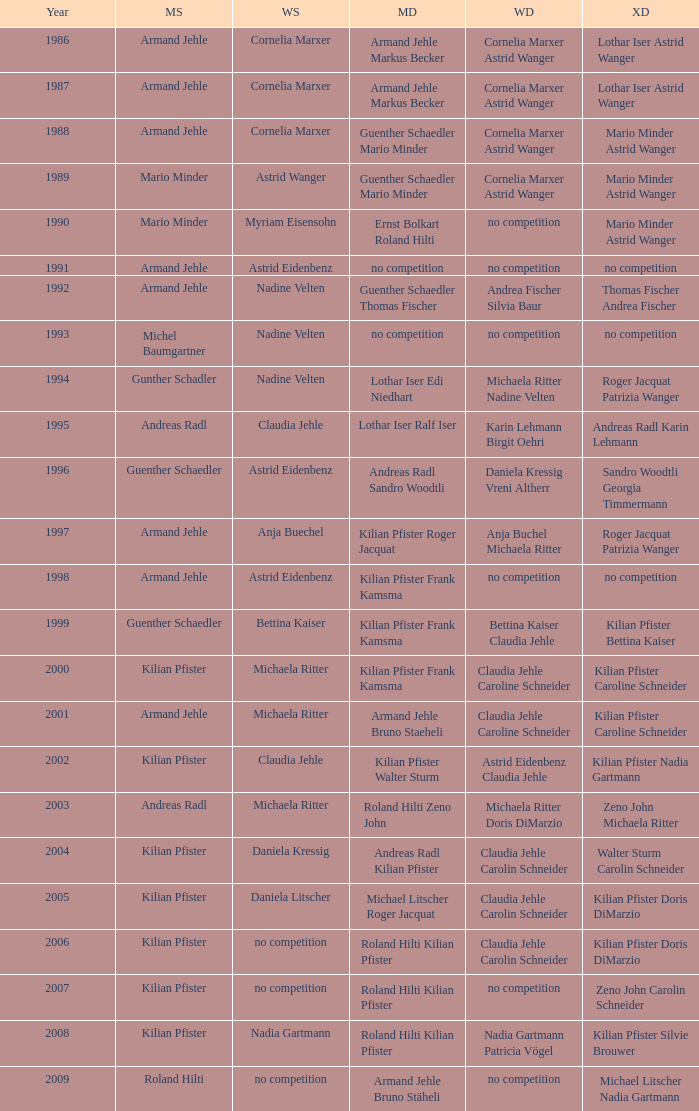What is the most current year where the women's doubles champions are astrid eidenbenz claudia jehle 2002.0. Would you be able to parse every entry in this table? {'header': ['Year', 'MS', 'WS', 'MD', 'WD', 'XD'], 'rows': [['1986', 'Armand Jehle', 'Cornelia Marxer', 'Armand Jehle Markus Becker', 'Cornelia Marxer Astrid Wanger', 'Lothar Iser Astrid Wanger'], ['1987', 'Armand Jehle', 'Cornelia Marxer', 'Armand Jehle Markus Becker', 'Cornelia Marxer Astrid Wanger', 'Lothar Iser Astrid Wanger'], ['1988', 'Armand Jehle', 'Cornelia Marxer', 'Guenther Schaedler Mario Minder', 'Cornelia Marxer Astrid Wanger', 'Mario Minder Astrid Wanger'], ['1989', 'Mario Minder', 'Astrid Wanger', 'Guenther Schaedler Mario Minder', 'Cornelia Marxer Astrid Wanger', 'Mario Minder Astrid Wanger'], ['1990', 'Mario Minder', 'Myriam Eisensohn', 'Ernst Bolkart Roland Hilti', 'no competition', 'Mario Minder Astrid Wanger'], ['1991', 'Armand Jehle', 'Astrid Eidenbenz', 'no competition', 'no competition', 'no competition'], ['1992', 'Armand Jehle', 'Nadine Velten', 'Guenther Schaedler Thomas Fischer', 'Andrea Fischer Silvia Baur', 'Thomas Fischer Andrea Fischer'], ['1993', 'Michel Baumgartner', 'Nadine Velten', 'no competition', 'no competition', 'no competition'], ['1994', 'Gunther Schadler', 'Nadine Velten', 'Lothar Iser Edi Niedhart', 'Michaela Ritter Nadine Velten', 'Roger Jacquat Patrizia Wanger'], ['1995', 'Andreas Radl', 'Claudia Jehle', 'Lothar Iser Ralf Iser', 'Karin Lehmann Birgit Oehri', 'Andreas Radl Karin Lehmann'], ['1996', 'Guenther Schaedler', 'Astrid Eidenbenz', 'Andreas Radl Sandro Woodtli', 'Daniela Kressig Vreni Altherr', 'Sandro Woodtli Georgia Timmermann'], ['1997', 'Armand Jehle', 'Anja Buechel', 'Kilian Pfister Roger Jacquat', 'Anja Buchel Michaela Ritter', 'Roger Jacquat Patrizia Wanger'], ['1998', 'Armand Jehle', 'Astrid Eidenbenz', 'Kilian Pfister Frank Kamsma', 'no competition', 'no competition'], ['1999', 'Guenther Schaedler', 'Bettina Kaiser', 'Kilian Pfister Frank Kamsma', 'Bettina Kaiser Claudia Jehle', 'Kilian Pfister Bettina Kaiser'], ['2000', 'Kilian Pfister', 'Michaela Ritter', 'Kilian Pfister Frank Kamsma', 'Claudia Jehle Caroline Schneider', 'Kilian Pfister Caroline Schneider'], ['2001', 'Armand Jehle', 'Michaela Ritter', 'Armand Jehle Bruno Staeheli', 'Claudia Jehle Caroline Schneider', 'Kilian Pfister Caroline Schneider'], ['2002', 'Kilian Pfister', 'Claudia Jehle', 'Kilian Pfister Walter Sturm', 'Astrid Eidenbenz Claudia Jehle', 'Kilian Pfister Nadia Gartmann'], ['2003', 'Andreas Radl', 'Michaela Ritter', 'Roland Hilti Zeno John', 'Michaela Ritter Doris DiMarzio', 'Zeno John Michaela Ritter'], ['2004', 'Kilian Pfister', 'Daniela Kressig', 'Andreas Radl Kilian Pfister', 'Claudia Jehle Carolin Schneider', 'Walter Sturm Carolin Schneider'], ['2005', 'Kilian Pfister', 'Daniela Litscher', 'Michael Litscher Roger Jacquat', 'Claudia Jehle Carolin Schneider', 'Kilian Pfister Doris DiMarzio'], ['2006', 'Kilian Pfister', 'no competition', 'Roland Hilti Kilian Pfister', 'Claudia Jehle Carolin Schneider', 'Kilian Pfister Doris DiMarzio'], ['2007', 'Kilian Pfister', 'no competition', 'Roland Hilti Kilian Pfister', 'no competition', 'Zeno John Carolin Schneider'], ['2008', 'Kilian Pfister', 'Nadia Gartmann', 'Roland Hilti Kilian Pfister', 'Nadia Gartmann Patricia Vögel', 'Kilian Pfister Silvie Brouwer'], ['2009', 'Roland Hilti', 'no competition', 'Armand Jehle Bruno Stäheli', 'no competition', 'Michael Litscher Nadia Gartmann']]} 